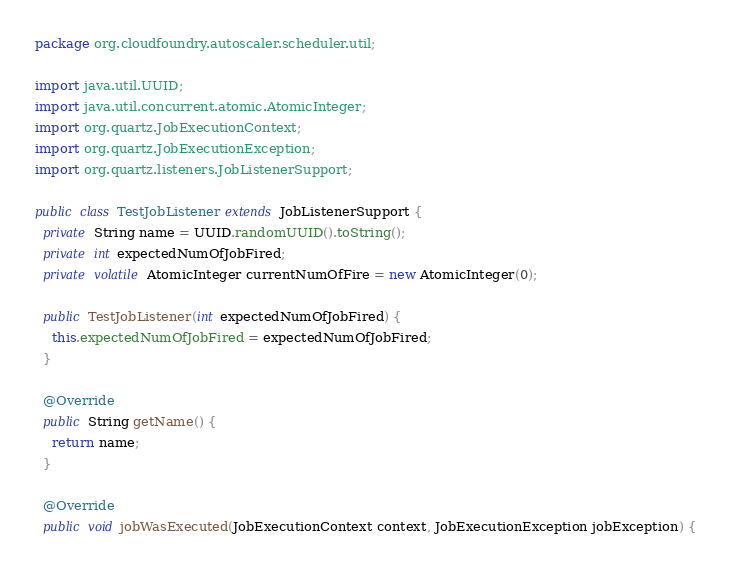<code> <loc_0><loc_0><loc_500><loc_500><_Java_>package org.cloudfoundry.autoscaler.scheduler.util;

import java.util.UUID;
import java.util.concurrent.atomic.AtomicInteger;
import org.quartz.JobExecutionContext;
import org.quartz.JobExecutionException;
import org.quartz.listeners.JobListenerSupport;

public class TestJobListener extends JobListenerSupport {
  private String name = UUID.randomUUID().toString();
  private int expectedNumOfJobFired;
  private volatile AtomicInteger currentNumOfFire = new AtomicInteger(0);

  public TestJobListener(int expectedNumOfJobFired) {
    this.expectedNumOfJobFired = expectedNumOfJobFired;
  }

  @Override
  public String getName() {
    return name;
  }

  @Override
  public void jobWasExecuted(JobExecutionContext context, JobExecutionException jobException) {</code> 